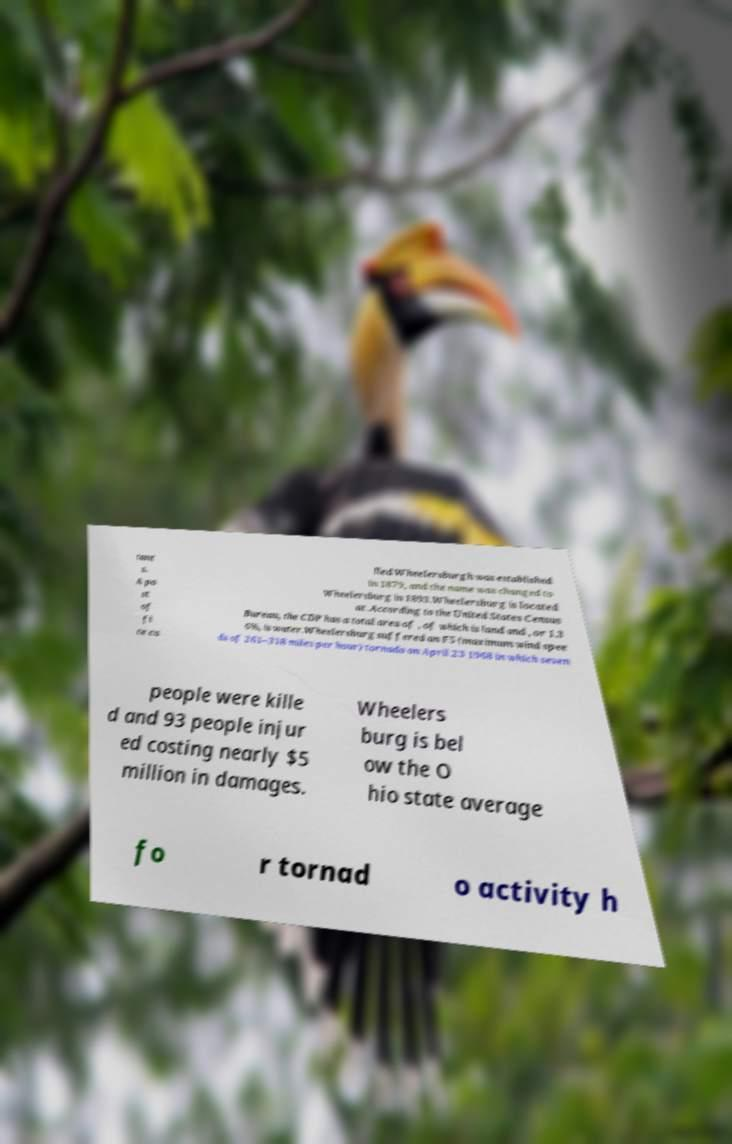I need the written content from this picture converted into text. Can you do that? tant s. A po st of fi ce ca lled Wheelersburgh was established in 1879, and the name was changed to Wheelersburg in 1893.Wheelersburg is located at .According to the United States Census Bureau, the CDP has a total area of , of which is land and , or 1.3 6%, is water.Wheelersburg suffered an F5 (maximum wind spee ds of 261–318 miles per hour) tornado on April 23 1968 in which seven people were kille d and 93 people injur ed costing nearly $5 million in damages. Wheelers burg is bel ow the O hio state average fo r tornad o activity h 